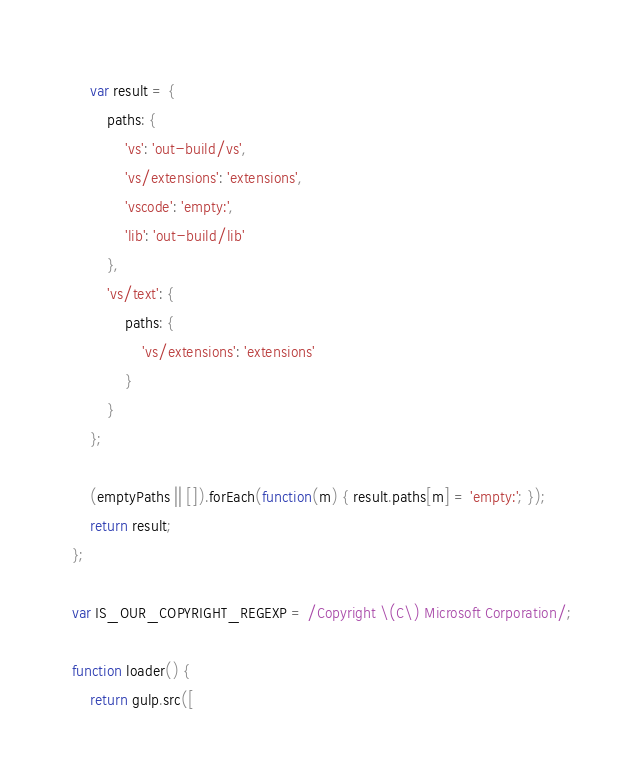Convert code to text. <code><loc_0><loc_0><loc_500><loc_500><_JavaScript_>	var result = {
		paths: {
			'vs': 'out-build/vs',
			'vs/extensions': 'extensions',
			'vscode': 'empty:',
			'lib': 'out-build/lib'
		},
		'vs/text': {
			paths: {
				'vs/extensions': 'extensions'
			}
		}
	};

	(emptyPaths || []).forEach(function(m) { result.paths[m] = 'empty:'; });
	return result;
};

var IS_OUR_COPYRIGHT_REGEXP = /Copyright \(C\) Microsoft Corporation/;

function loader() {
	return gulp.src([</code> 